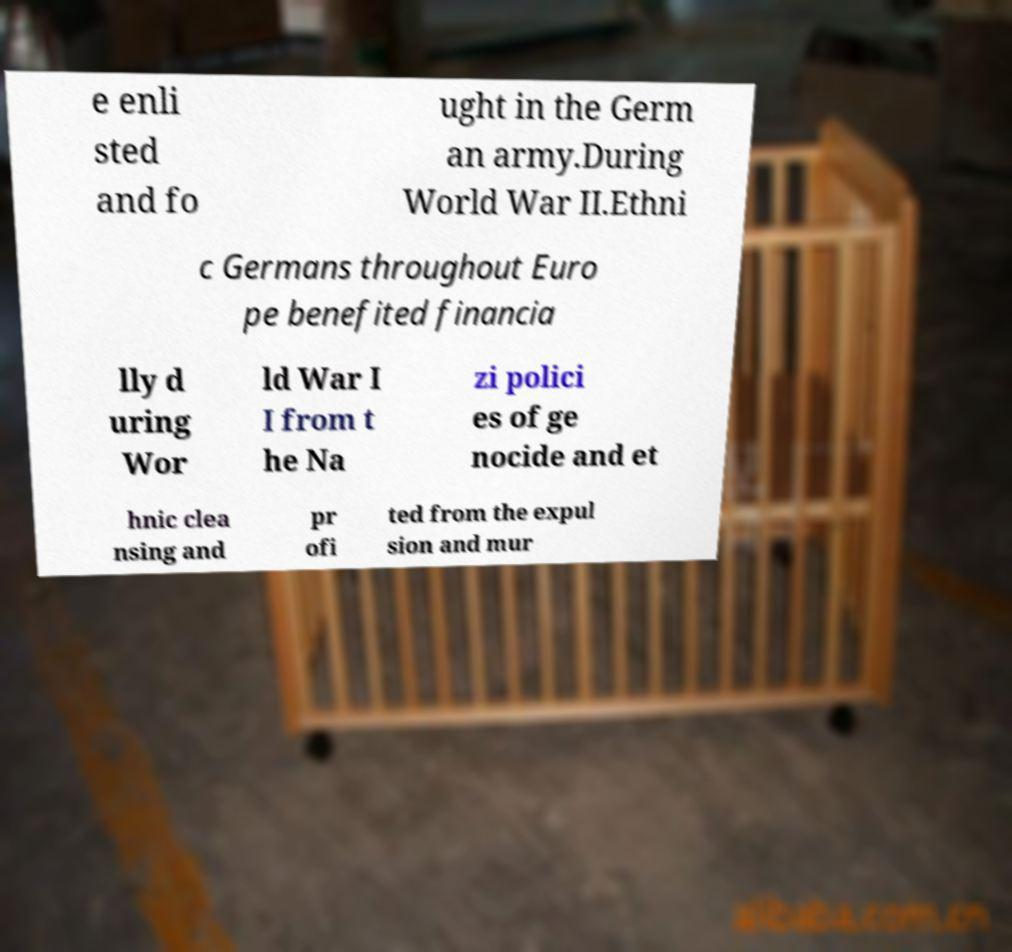Could you extract and type out the text from this image? e enli sted and fo ught in the Germ an army.During World War II.Ethni c Germans throughout Euro pe benefited financia lly d uring Wor ld War I I from t he Na zi polici es of ge nocide and et hnic clea nsing and pr ofi ted from the expul sion and mur 